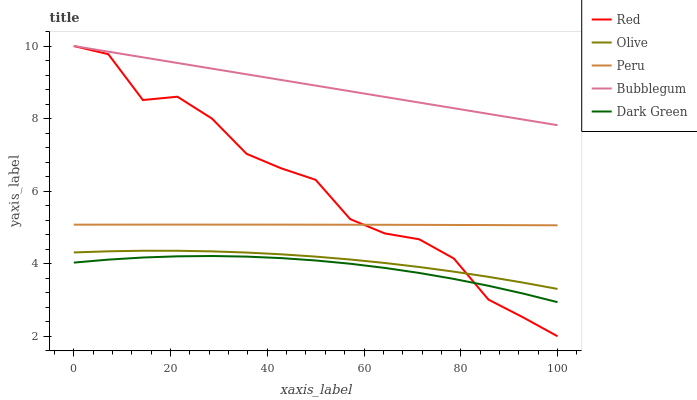Does Peru have the minimum area under the curve?
Answer yes or no. No. Does Peru have the maximum area under the curve?
Answer yes or no. No. Is Peru the smoothest?
Answer yes or no. No. Is Peru the roughest?
Answer yes or no. No. Does Peru have the lowest value?
Answer yes or no. No. Does Peru have the highest value?
Answer yes or no. No. Is Peru less than Bubblegum?
Answer yes or no. Yes. Is Peru greater than Olive?
Answer yes or no. Yes. Does Peru intersect Bubblegum?
Answer yes or no. No. 